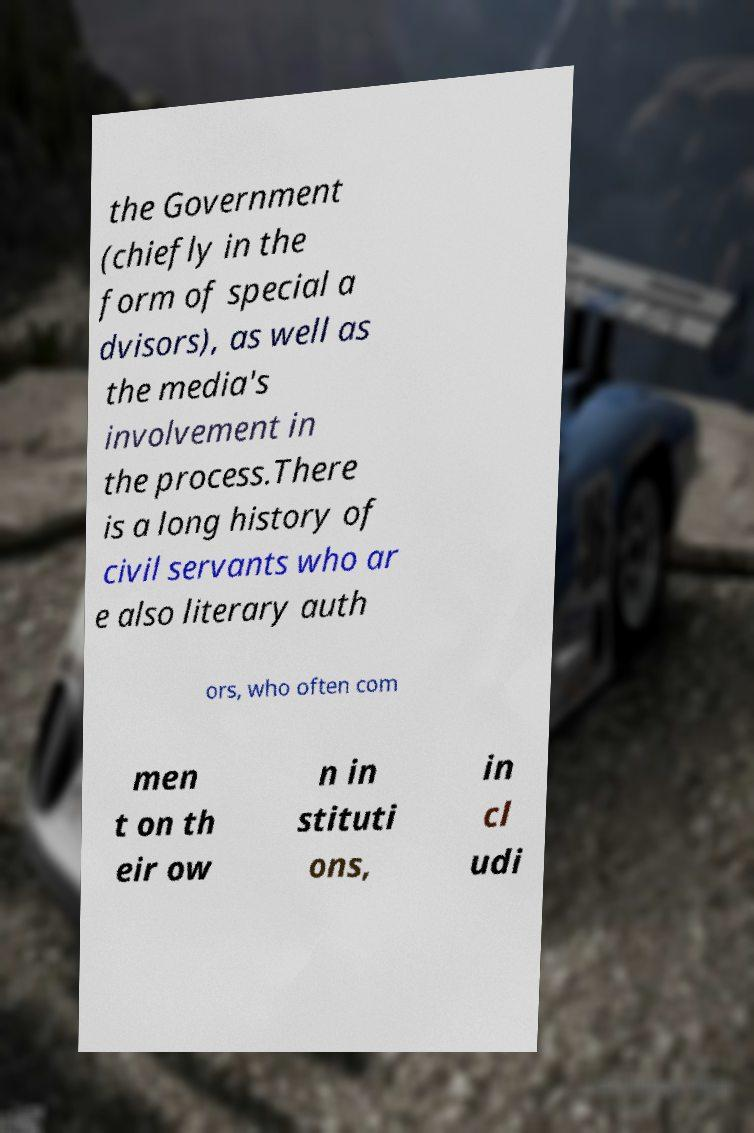For documentation purposes, I need the text within this image transcribed. Could you provide that? the Government (chiefly in the form of special a dvisors), as well as the media's involvement in the process.There is a long history of civil servants who ar e also literary auth ors, who often com men t on th eir ow n in stituti ons, in cl udi 